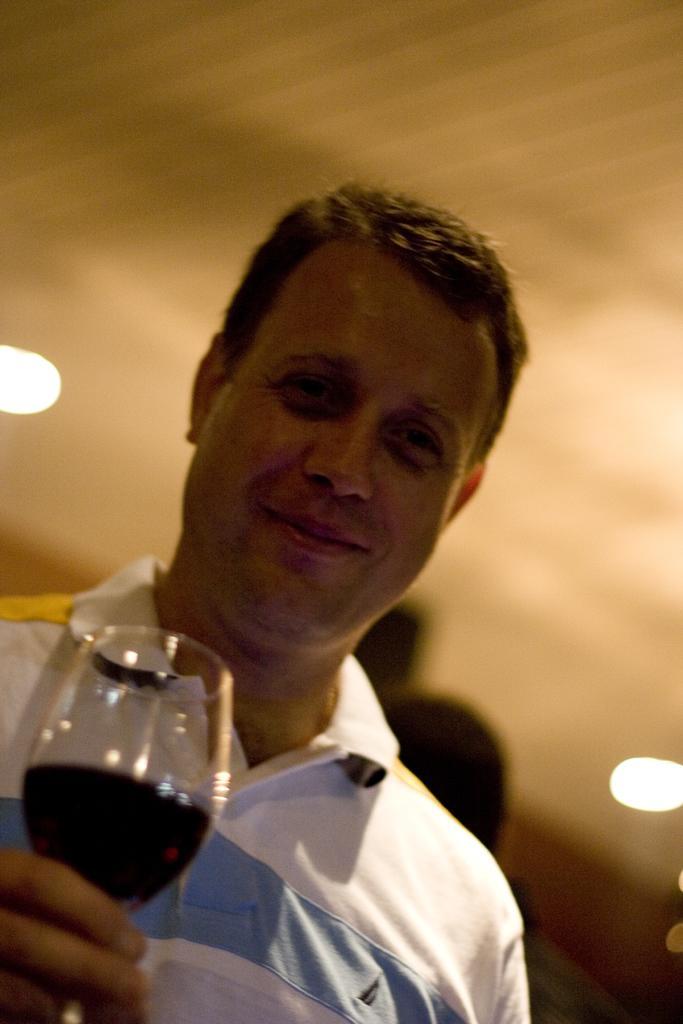Please provide a concise description of this image. In this image I can see the person wearing the white, yellow and blue color dress and holding the glass with drink. In the background I can see few more people and the lights in the top. 